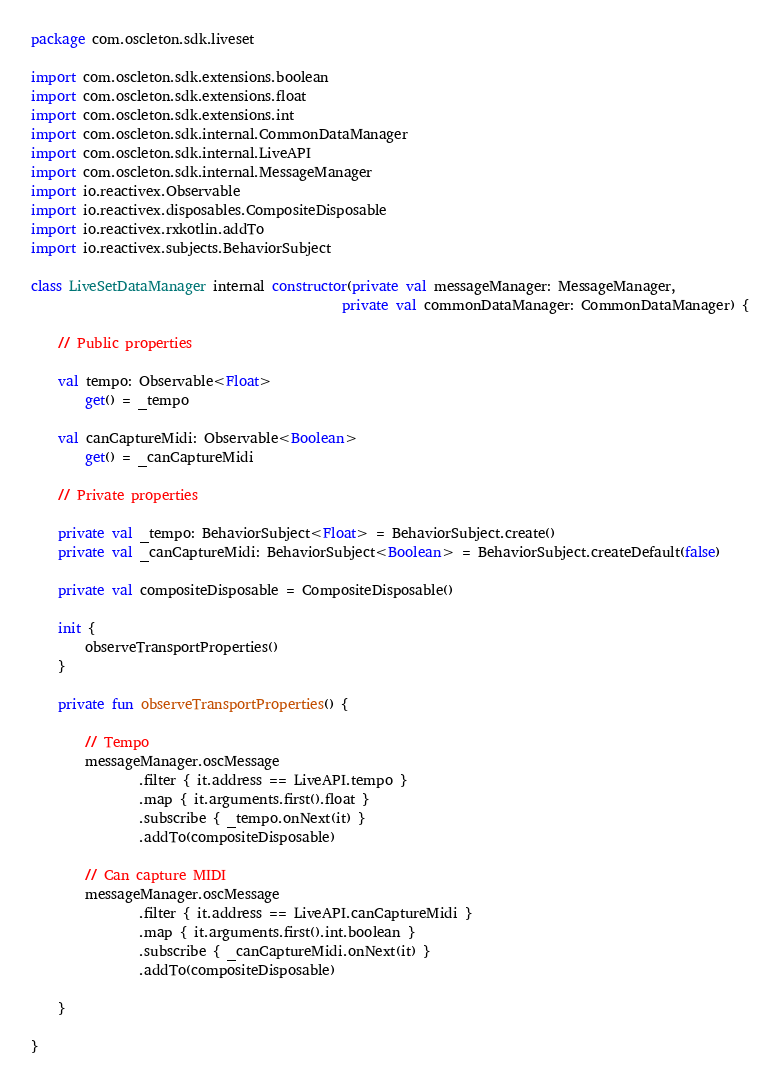<code> <loc_0><loc_0><loc_500><loc_500><_Kotlin_>package com.oscleton.sdk.liveset

import com.oscleton.sdk.extensions.boolean
import com.oscleton.sdk.extensions.float
import com.oscleton.sdk.extensions.int
import com.oscleton.sdk.internal.CommonDataManager
import com.oscleton.sdk.internal.LiveAPI
import com.oscleton.sdk.internal.MessageManager
import io.reactivex.Observable
import io.reactivex.disposables.CompositeDisposable
import io.reactivex.rxkotlin.addTo
import io.reactivex.subjects.BehaviorSubject

class LiveSetDataManager internal constructor(private val messageManager: MessageManager,
                                              private val commonDataManager: CommonDataManager) {

    // Public properties

    val tempo: Observable<Float>
        get() = _tempo

    val canCaptureMidi: Observable<Boolean>
        get() = _canCaptureMidi

    // Private properties

    private val _tempo: BehaviorSubject<Float> = BehaviorSubject.create()
    private val _canCaptureMidi: BehaviorSubject<Boolean> = BehaviorSubject.createDefault(false)

    private val compositeDisposable = CompositeDisposable()

    init {
        observeTransportProperties()
    }

    private fun observeTransportProperties() {

        // Tempo
        messageManager.oscMessage
                .filter { it.address == LiveAPI.tempo }
                .map { it.arguments.first().float }
                .subscribe { _tempo.onNext(it) }
                .addTo(compositeDisposable)

        // Can capture MIDI
        messageManager.oscMessage
                .filter { it.address == LiveAPI.canCaptureMidi }
                .map { it.arguments.first().int.boolean }
                .subscribe { _canCaptureMidi.onNext(it) }
                .addTo(compositeDisposable)

    }

}</code> 